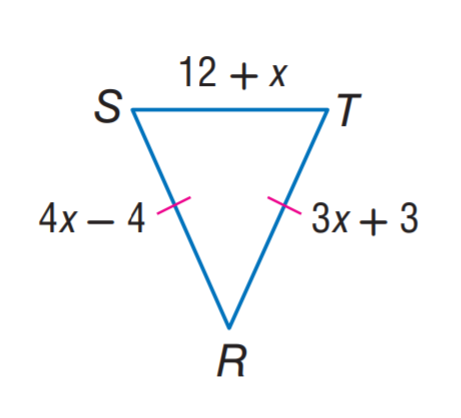Question: Find R T.
Choices:
A. 12
B. 24
C. 27
D. 28
Answer with the letter. Answer: B Question: Find S R.
Choices:
A. 12
B. 24
C. 27
D. 28
Answer with the letter. Answer: B Question: Find x.
Choices:
A. 3
B. 4
C. 7
D. 12
Answer with the letter. Answer: C 